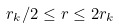Convert formula to latex. <formula><loc_0><loc_0><loc_500><loc_500>r _ { k } / 2 \leq r \leq 2 r _ { k }</formula> 